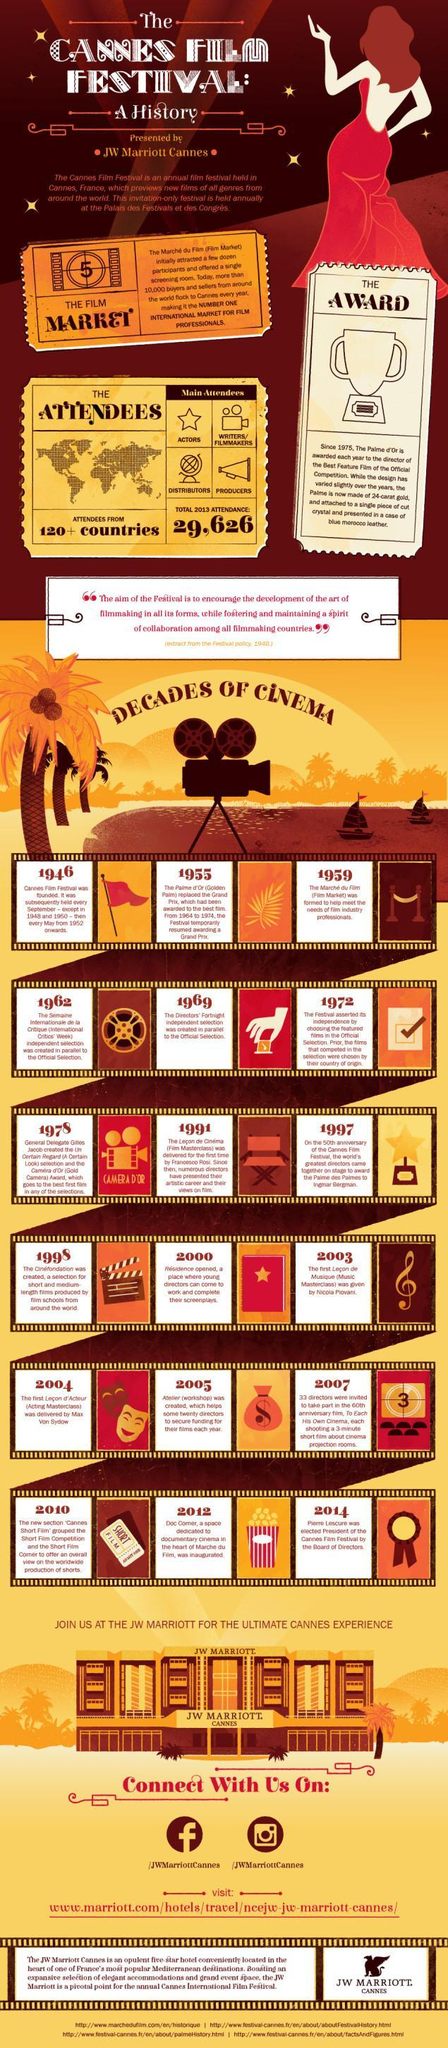When was the initial masterclass in Music taken ?
Answer the question with a short phrase. 2003 When was the first non-dependent selection committee corresponding to the official committee formed? 1969 Which year was the Grand Prix title swapped for the Golden Palm title for a short term ? 1955 